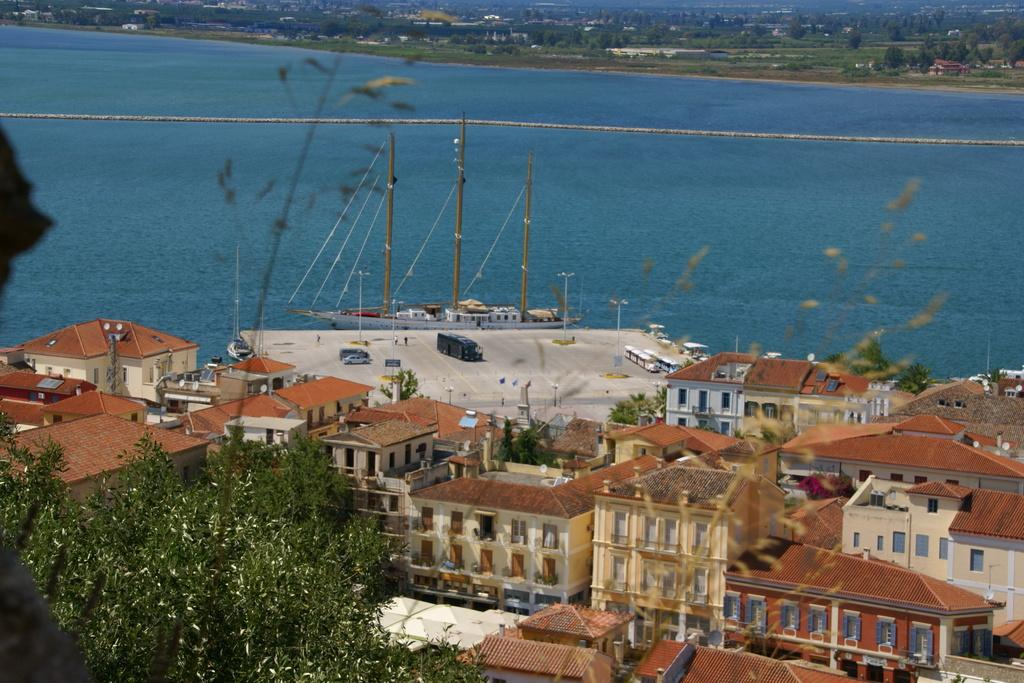What type of structures can be seen in the image? There are buildings in the image. What color are the trees in the image? The trees in the image have green color. What else can be seen in the background of the image? There are vehicles visible in the background. What is located on the water in the image? There is a ship on the water in the image. Can you tell me how many crackers are on the ship in the image? There are no crackers present in the image; it features a ship on the water. What type of produce is being harvested by the brother in the image? There is no brother or produce present in the image. 